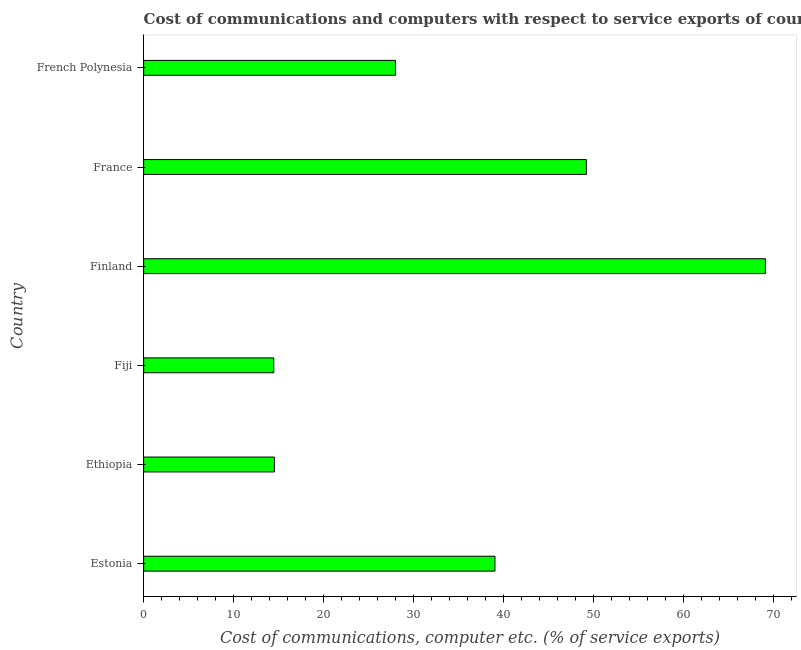Does the graph contain grids?
Keep it short and to the point. No. What is the title of the graph?
Provide a succinct answer. Cost of communications and computers with respect to service exports of countries in 2012. What is the label or title of the X-axis?
Offer a terse response. Cost of communications, computer etc. (% of service exports). What is the label or title of the Y-axis?
Keep it short and to the point. Country. What is the cost of communications and computer in Ethiopia?
Your response must be concise. 14.54. Across all countries, what is the maximum cost of communications and computer?
Your answer should be compact. 69.15. Across all countries, what is the minimum cost of communications and computer?
Your answer should be compact. 14.47. In which country was the cost of communications and computer minimum?
Offer a terse response. Fiji. What is the sum of the cost of communications and computer?
Provide a short and direct response. 214.48. What is the difference between the cost of communications and computer in Estonia and France?
Offer a terse response. -10.17. What is the average cost of communications and computer per country?
Your response must be concise. 35.75. What is the median cost of communications and computer?
Offer a very short reply. 33.54. What is the ratio of the cost of communications and computer in Estonia to that in France?
Make the answer very short. 0.79. Is the difference between the cost of communications and computer in Estonia and French Polynesia greater than the difference between any two countries?
Provide a succinct answer. No. What is the difference between the highest and the second highest cost of communications and computer?
Your answer should be very brief. 19.91. What is the difference between the highest and the lowest cost of communications and computer?
Offer a terse response. 54.68. In how many countries, is the cost of communications and computer greater than the average cost of communications and computer taken over all countries?
Your answer should be compact. 3. Are all the bars in the graph horizontal?
Your response must be concise. Yes. How many countries are there in the graph?
Offer a very short reply. 6. What is the difference between two consecutive major ticks on the X-axis?
Your answer should be very brief. 10. Are the values on the major ticks of X-axis written in scientific E-notation?
Your answer should be compact. No. What is the Cost of communications, computer etc. (% of service exports) of Estonia?
Ensure brevity in your answer.  39.07. What is the Cost of communications, computer etc. (% of service exports) in Ethiopia?
Provide a short and direct response. 14.54. What is the Cost of communications, computer etc. (% of service exports) in Fiji?
Make the answer very short. 14.47. What is the Cost of communications, computer etc. (% of service exports) in Finland?
Make the answer very short. 69.15. What is the Cost of communications, computer etc. (% of service exports) of France?
Offer a very short reply. 49.24. What is the Cost of communications, computer etc. (% of service exports) of French Polynesia?
Ensure brevity in your answer.  28.01. What is the difference between the Cost of communications, computer etc. (% of service exports) in Estonia and Ethiopia?
Your answer should be very brief. 24.53. What is the difference between the Cost of communications, computer etc. (% of service exports) in Estonia and Fiji?
Your answer should be very brief. 24.6. What is the difference between the Cost of communications, computer etc. (% of service exports) in Estonia and Finland?
Offer a terse response. -30.08. What is the difference between the Cost of communications, computer etc. (% of service exports) in Estonia and France?
Your answer should be compact. -10.17. What is the difference between the Cost of communications, computer etc. (% of service exports) in Estonia and French Polynesia?
Provide a short and direct response. 11.06. What is the difference between the Cost of communications, computer etc. (% of service exports) in Ethiopia and Fiji?
Offer a terse response. 0.07. What is the difference between the Cost of communications, computer etc. (% of service exports) in Ethiopia and Finland?
Ensure brevity in your answer.  -54.6. What is the difference between the Cost of communications, computer etc. (% of service exports) in Ethiopia and France?
Ensure brevity in your answer.  -34.7. What is the difference between the Cost of communications, computer etc. (% of service exports) in Ethiopia and French Polynesia?
Give a very brief answer. -13.46. What is the difference between the Cost of communications, computer etc. (% of service exports) in Fiji and Finland?
Your response must be concise. -54.68. What is the difference between the Cost of communications, computer etc. (% of service exports) in Fiji and France?
Make the answer very short. -34.77. What is the difference between the Cost of communications, computer etc. (% of service exports) in Fiji and French Polynesia?
Keep it short and to the point. -13.54. What is the difference between the Cost of communications, computer etc. (% of service exports) in Finland and France?
Ensure brevity in your answer.  19.91. What is the difference between the Cost of communications, computer etc. (% of service exports) in Finland and French Polynesia?
Offer a terse response. 41.14. What is the difference between the Cost of communications, computer etc. (% of service exports) in France and French Polynesia?
Provide a succinct answer. 21.23. What is the ratio of the Cost of communications, computer etc. (% of service exports) in Estonia to that in Ethiopia?
Provide a succinct answer. 2.69. What is the ratio of the Cost of communications, computer etc. (% of service exports) in Estonia to that in Fiji?
Provide a succinct answer. 2.7. What is the ratio of the Cost of communications, computer etc. (% of service exports) in Estonia to that in Finland?
Give a very brief answer. 0.56. What is the ratio of the Cost of communications, computer etc. (% of service exports) in Estonia to that in France?
Ensure brevity in your answer.  0.79. What is the ratio of the Cost of communications, computer etc. (% of service exports) in Estonia to that in French Polynesia?
Your response must be concise. 1.4. What is the ratio of the Cost of communications, computer etc. (% of service exports) in Ethiopia to that in Fiji?
Offer a terse response. 1. What is the ratio of the Cost of communications, computer etc. (% of service exports) in Ethiopia to that in Finland?
Give a very brief answer. 0.21. What is the ratio of the Cost of communications, computer etc. (% of service exports) in Ethiopia to that in France?
Your answer should be compact. 0.29. What is the ratio of the Cost of communications, computer etc. (% of service exports) in Ethiopia to that in French Polynesia?
Offer a terse response. 0.52. What is the ratio of the Cost of communications, computer etc. (% of service exports) in Fiji to that in Finland?
Your response must be concise. 0.21. What is the ratio of the Cost of communications, computer etc. (% of service exports) in Fiji to that in France?
Ensure brevity in your answer.  0.29. What is the ratio of the Cost of communications, computer etc. (% of service exports) in Fiji to that in French Polynesia?
Your answer should be compact. 0.52. What is the ratio of the Cost of communications, computer etc. (% of service exports) in Finland to that in France?
Keep it short and to the point. 1.4. What is the ratio of the Cost of communications, computer etc. (% of service exports) in Finland to that in French Polynesia?
Ensure brevity in your answer.  2.47. What is the ratio of the Cost of communications, computer etc. (% of service exports) in France to that in French Polynesia?
Ensure brevity in your answer.  1.76. 